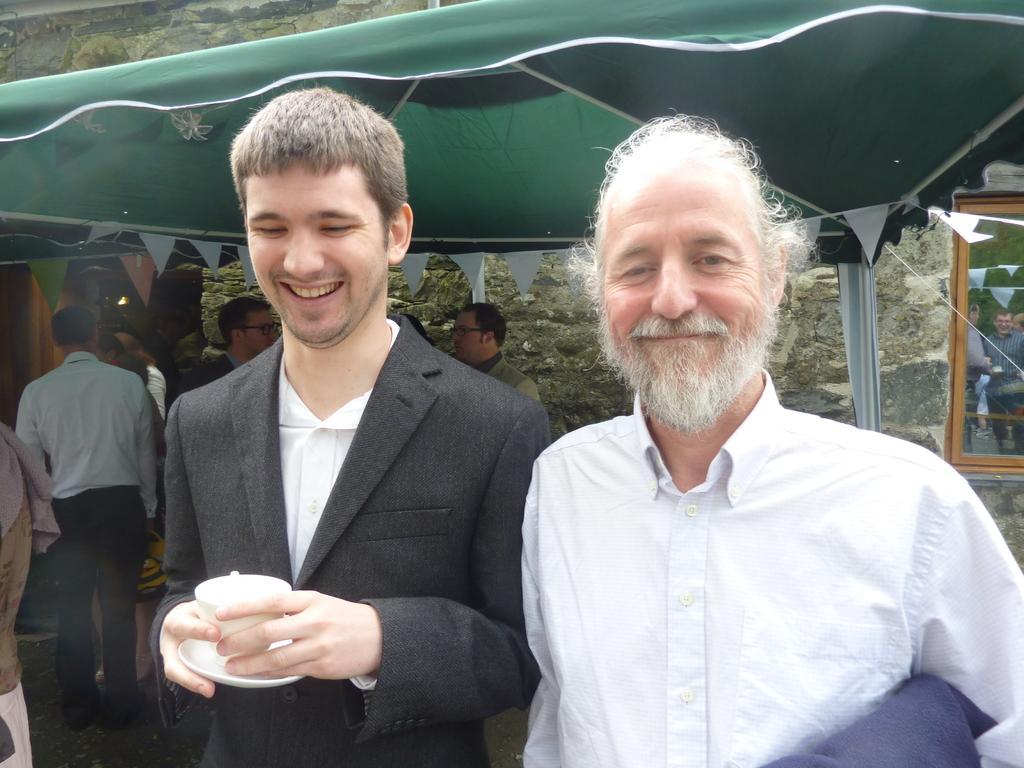Can you describe this image briefly? In this image we can see a few people, one of them is holding a cup, there is a tent, window, also we can see the wall. 